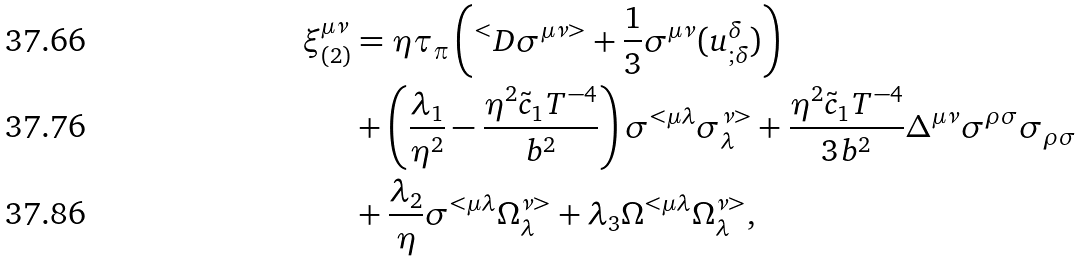<formula> <loc_0><loc_0><loc_500><loc_500>\xi ^ { \mu \nu } _ { ( 2 ) } & = \eta \tau _ { \pi } \left ( ^ { < } D \sigma ^ { \mu \nu > } + \frac { 1 } { 3 } \sigma ^ { \mu \nu } ( u ^ { \delta } _ { ; \delta } ) \right ) \\ & + \left ( \frac { \lambda _ { 1 } } { \eta ^ { 2 } } - \frac { \eta ^ { 2 } \tilde { c } _ { 1 } T ^ { - 4 } } { b ^ { 2 } } \right ) \sigma ^ { < \mu \lambda } \sigma _ { \lambda } ^ { \nu > } + \frac { \eta ^ { 2 } \tilde { c } _ { 1 } T ^ { - 4 } } { 3 b ^ { 2 } } \Delta ^ { \mu \nu } \sigma ^ { \rho \sigma } \sigma _ { \rho \sigma } \\ & + \frac { \lambda _ { 2 } } { \eta } \sigma ^ { < \mu \lambda } \Omega ^ { \nu > } _ { \lambda } + \lambda _ { 3 } \Omega ^ { < \mu \lambda } \Omega _ { \lambda } ^ { \nu > } ,</formula> 